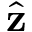<formula> <loc_0><loc_0><loc_500><loc_500>\hat { z }</formula> 